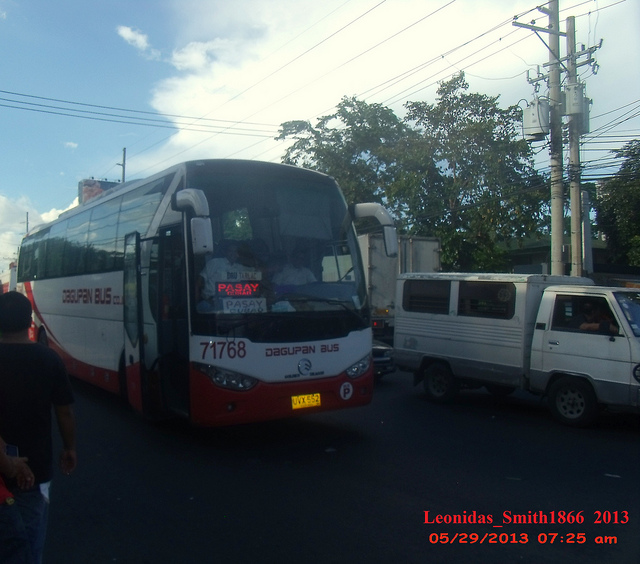Identify the text contained in this image. PARAY PASAY 71768 DAGUPAN BUS am 25 07 2013 29 05 2013 Smith 1866 Leonnids P BUS 